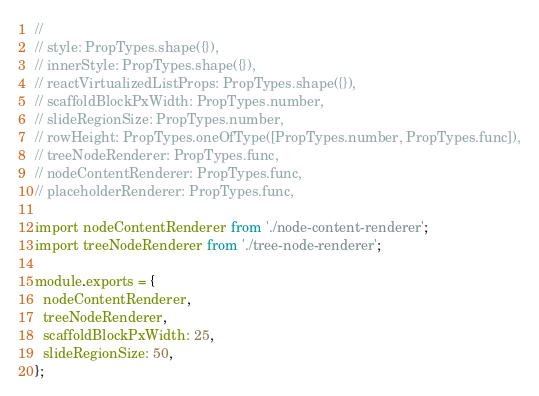<code> <loc_0><loc_0><loc_500><loc_500><_JavaScript_>//
// style: PropTypes.shape({}),
// innerStyle: PropTypes.shape({}),
// reactVirtualizedListProps: PropTypes.shape({}),
// scaffoldBlockPxWidth: PropTypes.number,
// slideRegionSize: PropTypes.number,
// rowHeight: PropTypes.oneOfType([PropTypes.number, PropTypes.func]),
// treeNodeRenderer: PropTypes.func,
// nodeContentRenderer: PropTypes.func,
// placeholderRenderer: PropTypes.func,

import nodeContentRenderer from './node-content-renderer';
import treeNodeRenderer from './tree-node-renderer';

module.exports = {
  nodeContentRenderer,
  treeNodeRenderer,
  scaffoldBlockPxWidth: 25,
  slideRegionSize: 50,
};
</code> 